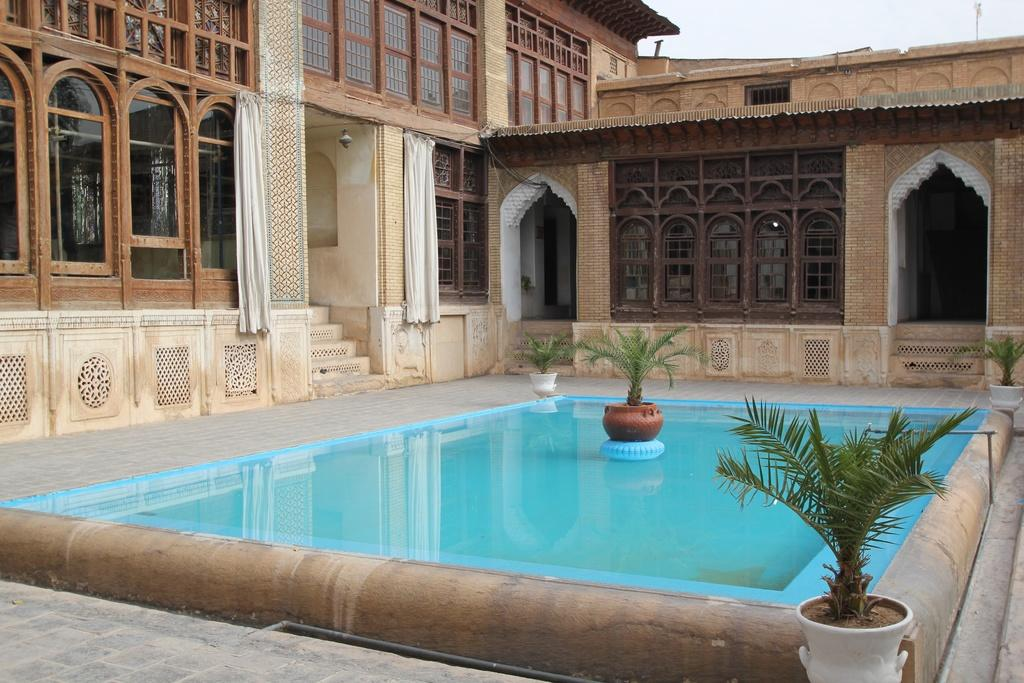What type of structure is present in the image? There is a building in the image. What type of window treatment is visible in the image? There are curtains in the image. What can be seen at the bottom of the image? There is water visible at the bottom of the image. What type of vegetation is present in the image? There are plants in the image. What surface is visible beneath the water? There is a floor in the image. What is visible at the top of the image? The sky is visible at the top of the image. What type of ink is used to color the plants in the image? There is no ink present in the image; the plants are naturally colored. What type of religion is practiced in the building depicted in the image? There is no information about the religion practiced in the building in the image. 